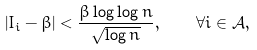Convert formula to latex. <formula><loc_0><loc_0><loc_500><loc_500>\left | I _ { i } - \beta \right | < \frac { \beta \log \log n } { \sqrt { \log n } } , \quad \forall i \in \mathcal { A } ,</formula> 